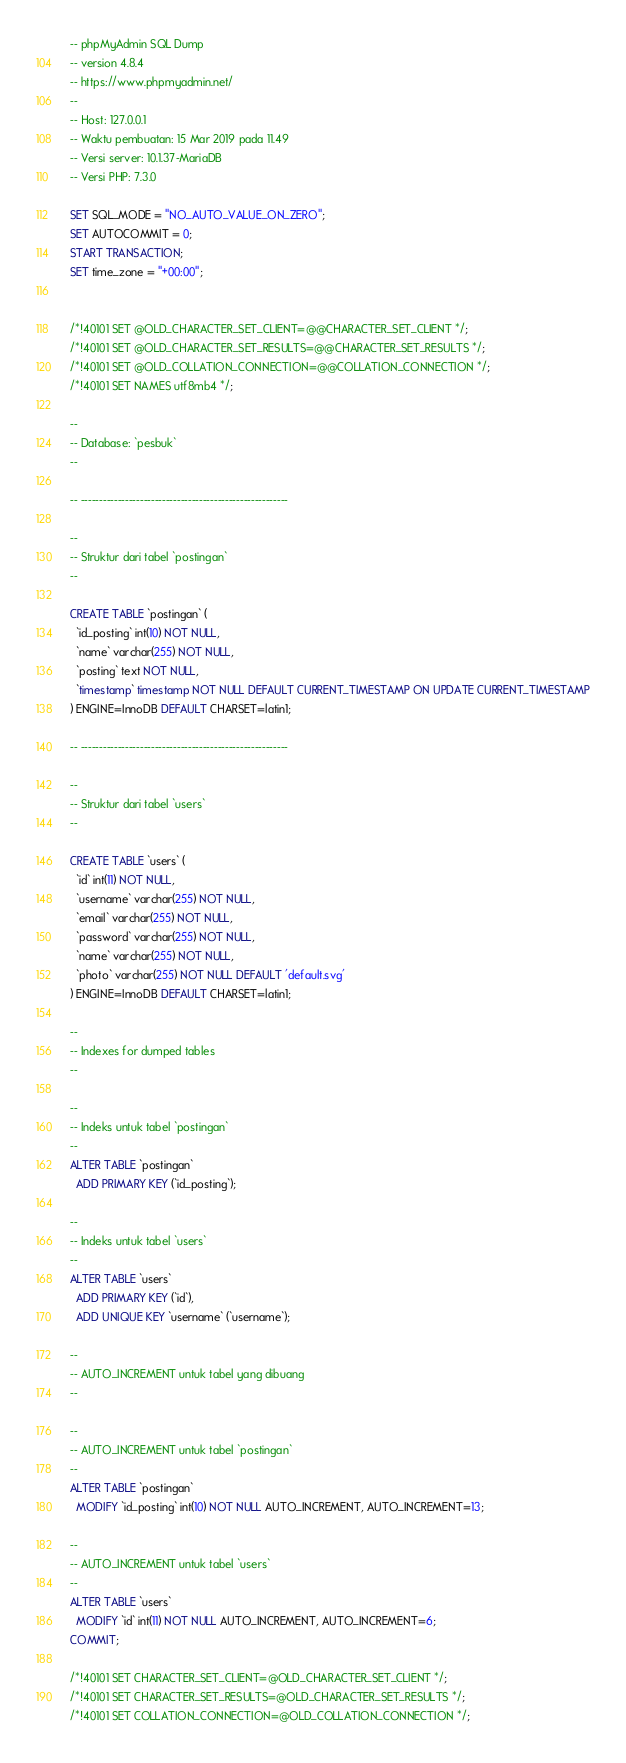Convert code to text. <code><loc_0><loc_0><loc_500><loc_500><_SQL_>-- phpMyAdmin SQL Dump
-- version 4.8.4
-- https://www.phpmyadmin.net/
--
-- Host: 127.0.0.1
-- Waktu pembuatan: 15 Mar 2019 pada 11.49
-- Versi server: 10.1.37-MariaDB
-- Versi PHP: 7.3.0

SET SQL_MODE = "NO_AUTO_VALUE_ON_ZERO";
SET AUTOCOMMIT = 0;
START TRANSACTION;
SET time_zone = "+00:00";


/*!40101 SET @OLD_CHARACTER_SET_CLIENT=@@CHARACTER_SET_CLIENT */;
/*!40101 SET @OLD_CHARACTER_SET_RESULTS=@@CHARACTER_SET_RESULTS */;
/*!40101 SET @OLD_COLLATION_CONNECTION=@@COLLATION_CONNECTION */;
/*!40101 SET NAMES utf8mb4 */;

--
-- Database: `pesbuk`
--

-- --------------------------------------------------------

--
-- Struktur dari tabel `postingan`
--

CREATE TABLE `postingan` (
  `id_posting` int(10) NOT NULL,
  `name` varchar(255) NOT NULL,
  `posting` text NOT NULL,
  `timestamp` timestamp NOT NULL DEFAULT CURRENT_TIMESTAMP ON UPDATE CURRENT_TIMESTAMP
) ENGINE=InnoDB DEFAULT CHARSET=latin1;

-- --------------------------------------------------------

--
-- Struktur dari tabel `users`
--

CREATE TABLE `users` (
  `id` int(11) NOT NULL,
  `username` varchar(255) NOT NULL,
  `email` varchar(255) NOT NULL,
  `password` varchar(255) NOT NULL,
  `name` varchar(255) NOT NULL,
  `photo` varchar(255) NOT NULL DEFAULT 'default.svg'
) ENGINE=InnoDB DEFAULT CHARSET=latin1;

--
-- Indexes for dumped tables
--

--
-- Indeks untuk tabel `postingan`
--
ALTER TABLE `postingan`
  ADD PRIMARY KEY (`id_posting`);

--
-- Indeks untuk tabel `users`
--
ALTER TABLE `users`
  ADD PRIMARY KEY (`id`),
  ADD UNIQUE KEY `username` (`username`);

--
-- AUTO_INCREMENT untuk tabel yang dibuang
--

--
-- AUTO_INCREMENT untuk tabel `postingan`
--
ALTER TABLE `postingan`
  MODIFY `id_posting` int(10) NOT NULL AUTO_INCREMENT, AUTO_INCREMENT=13;

--
-- AUTO_INCREMENT untuk tabel `users`
--
ALTER TABLE `users`
  MODIFY `id` int(11) NOT NULL AUTO_INCREMENT, AUTO_INCREMENT=6;
COMMIT;

/*!40101 SET CHARACTER_SET_CLIENT=@OLD_CHARACTER_SET_CLIENT */;
/*!40101 SET CHARACTER_SET_RESULTS=@OLD_CHARACTER_SET_RESULTS */;
/*!40101 SET COLLATION_CONNECTION=@OLD_COLLATION_CONNECTION */;
</code> 